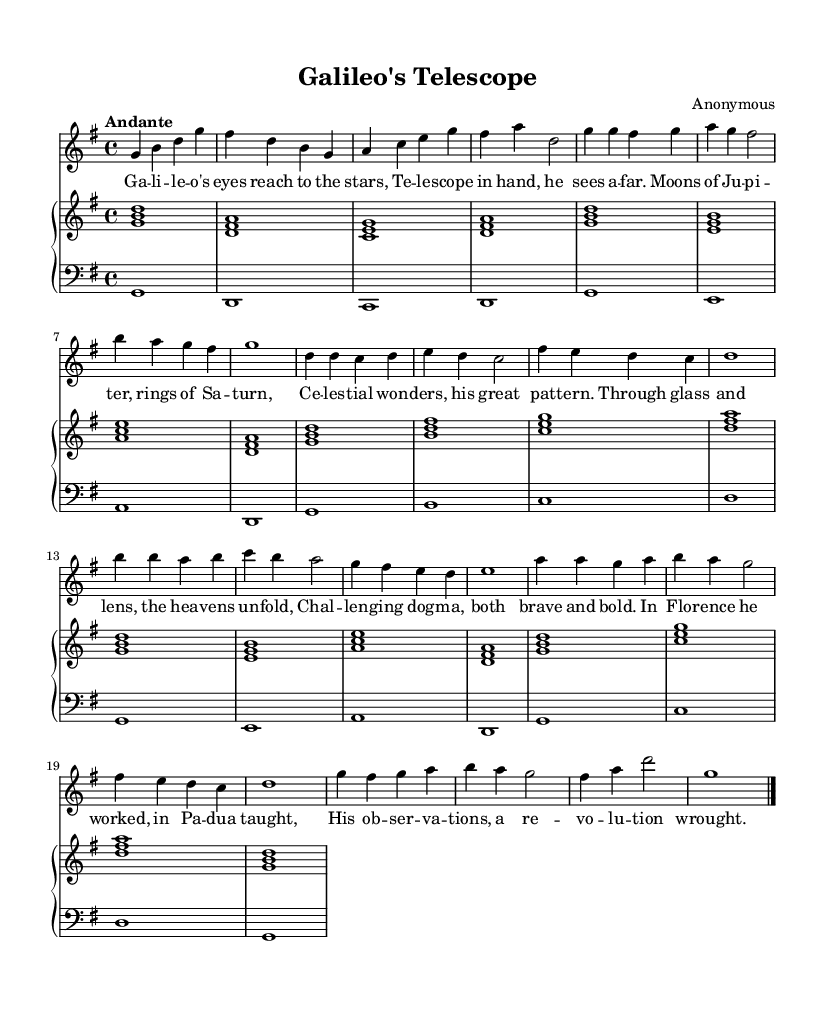What is the title of this piece? The title is indicated in the header section of the sheet music as "Galileo's Telescope."
Answer: Galileo's Telescope What key is this piece written in? The key signature is listed in the global section of the music as G major, which has one sharp (F#).
Answer: G major What is the time signature of this piece? The time signature is given in the global section as 4/4, indicating four beats per measure.
Answer: 4/4 What is the tempo marking of this piece? The tempo marking "Andante" appears in the global section, suggesting a moderately slow tempo.
Answer: Andante How many sections does the piece have? The structure of the piece shows clearly defined sections: A, B, and a Coda, totaling three distinct sections.
Answer: Three What significant figure is depicted in the lyrics? The lyrics reference "Galileo," who is a historical figure known for his contributions to science and astronomy.
Answer: Galileo What is the thematic focus of the lyrics? The lyrics describe Galileo's achievements and observations in astronomy, highlighting his use of the telescope.
Answer: Astronomy 